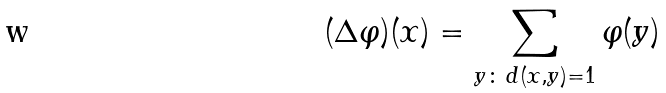<formula> <loc_0><loc_0><loc_500><loc_500>( \Delta \varphi ) ( x ) = \sum _ { y \colon \, d ( x , y ) = 1 } \varphi ( y )</formula> 